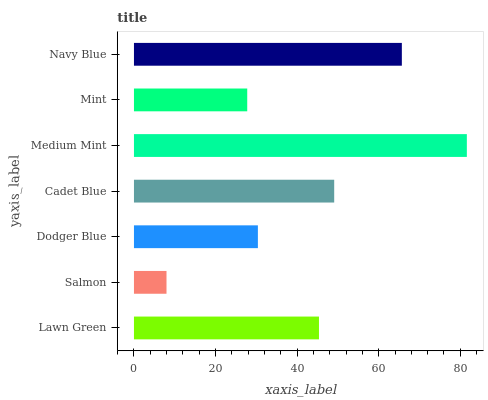Is Salmon the minimum?
Answer yes or no. Yes. Is Medium Mint the maximum?
Answer yes or no. Yes. Is Dodger Blue the minimum?
Answer yes or no. No. Is Dodger Blue the maximum?
Answer yes or no. No. Is Dodger Blue greater than Salmon?
Answer yes or no. Yes. Is Salmon less than Dodger Blue?
Answer yes or no. Yes. Is Salmon greater than Dodger Blue?
Answer yes or no. No. Is Dodger Blue less than Salmon?
Answer yes or no. No. Is Lawn Green the high median?
Answer yes or no. Yes. Is Lawn Green the low median?
Answer yes or no. Yes. Is Navy Blue the high median?
Answer yes or no. No. Is Navy Blue the low median?
Answer yes or no. No. 